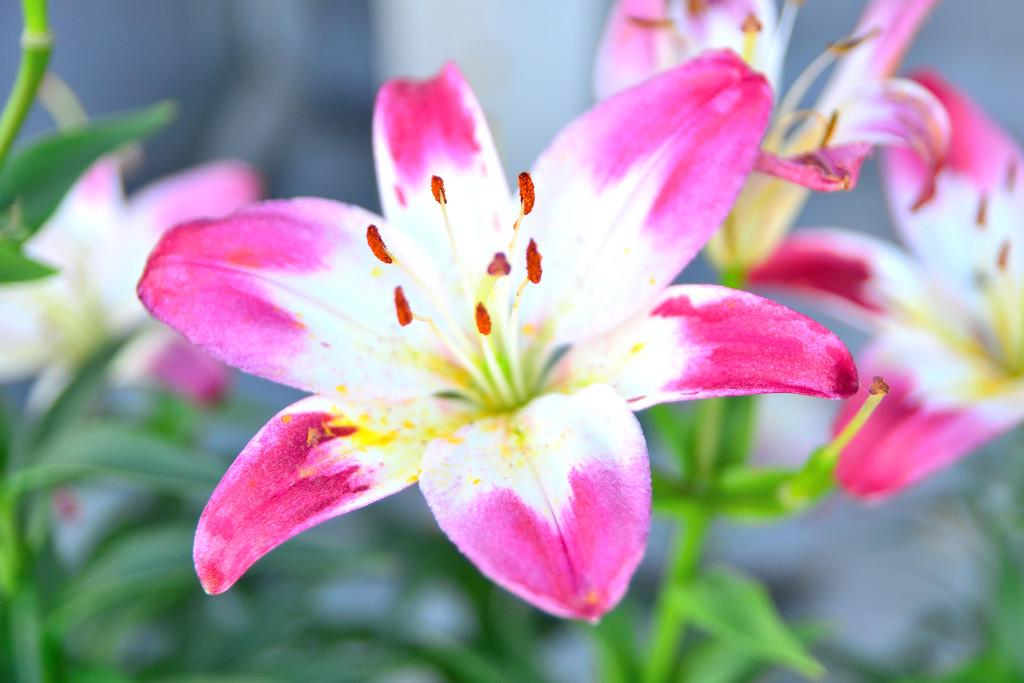What is located in the foreground of the image? There are flowers in the foreground of the image. What are the flowers attached to? The flowers are on a plant. Can you describe the background of the image? The background of the image is blurry. How many brothers are depicted in the image? There are no brothers present in the image; it features flowers on a plant with a blurry background. What type of joke is being told by the flowers in the image? There is no joke being told by the flowers in the image; they are simply plants with flowers. 